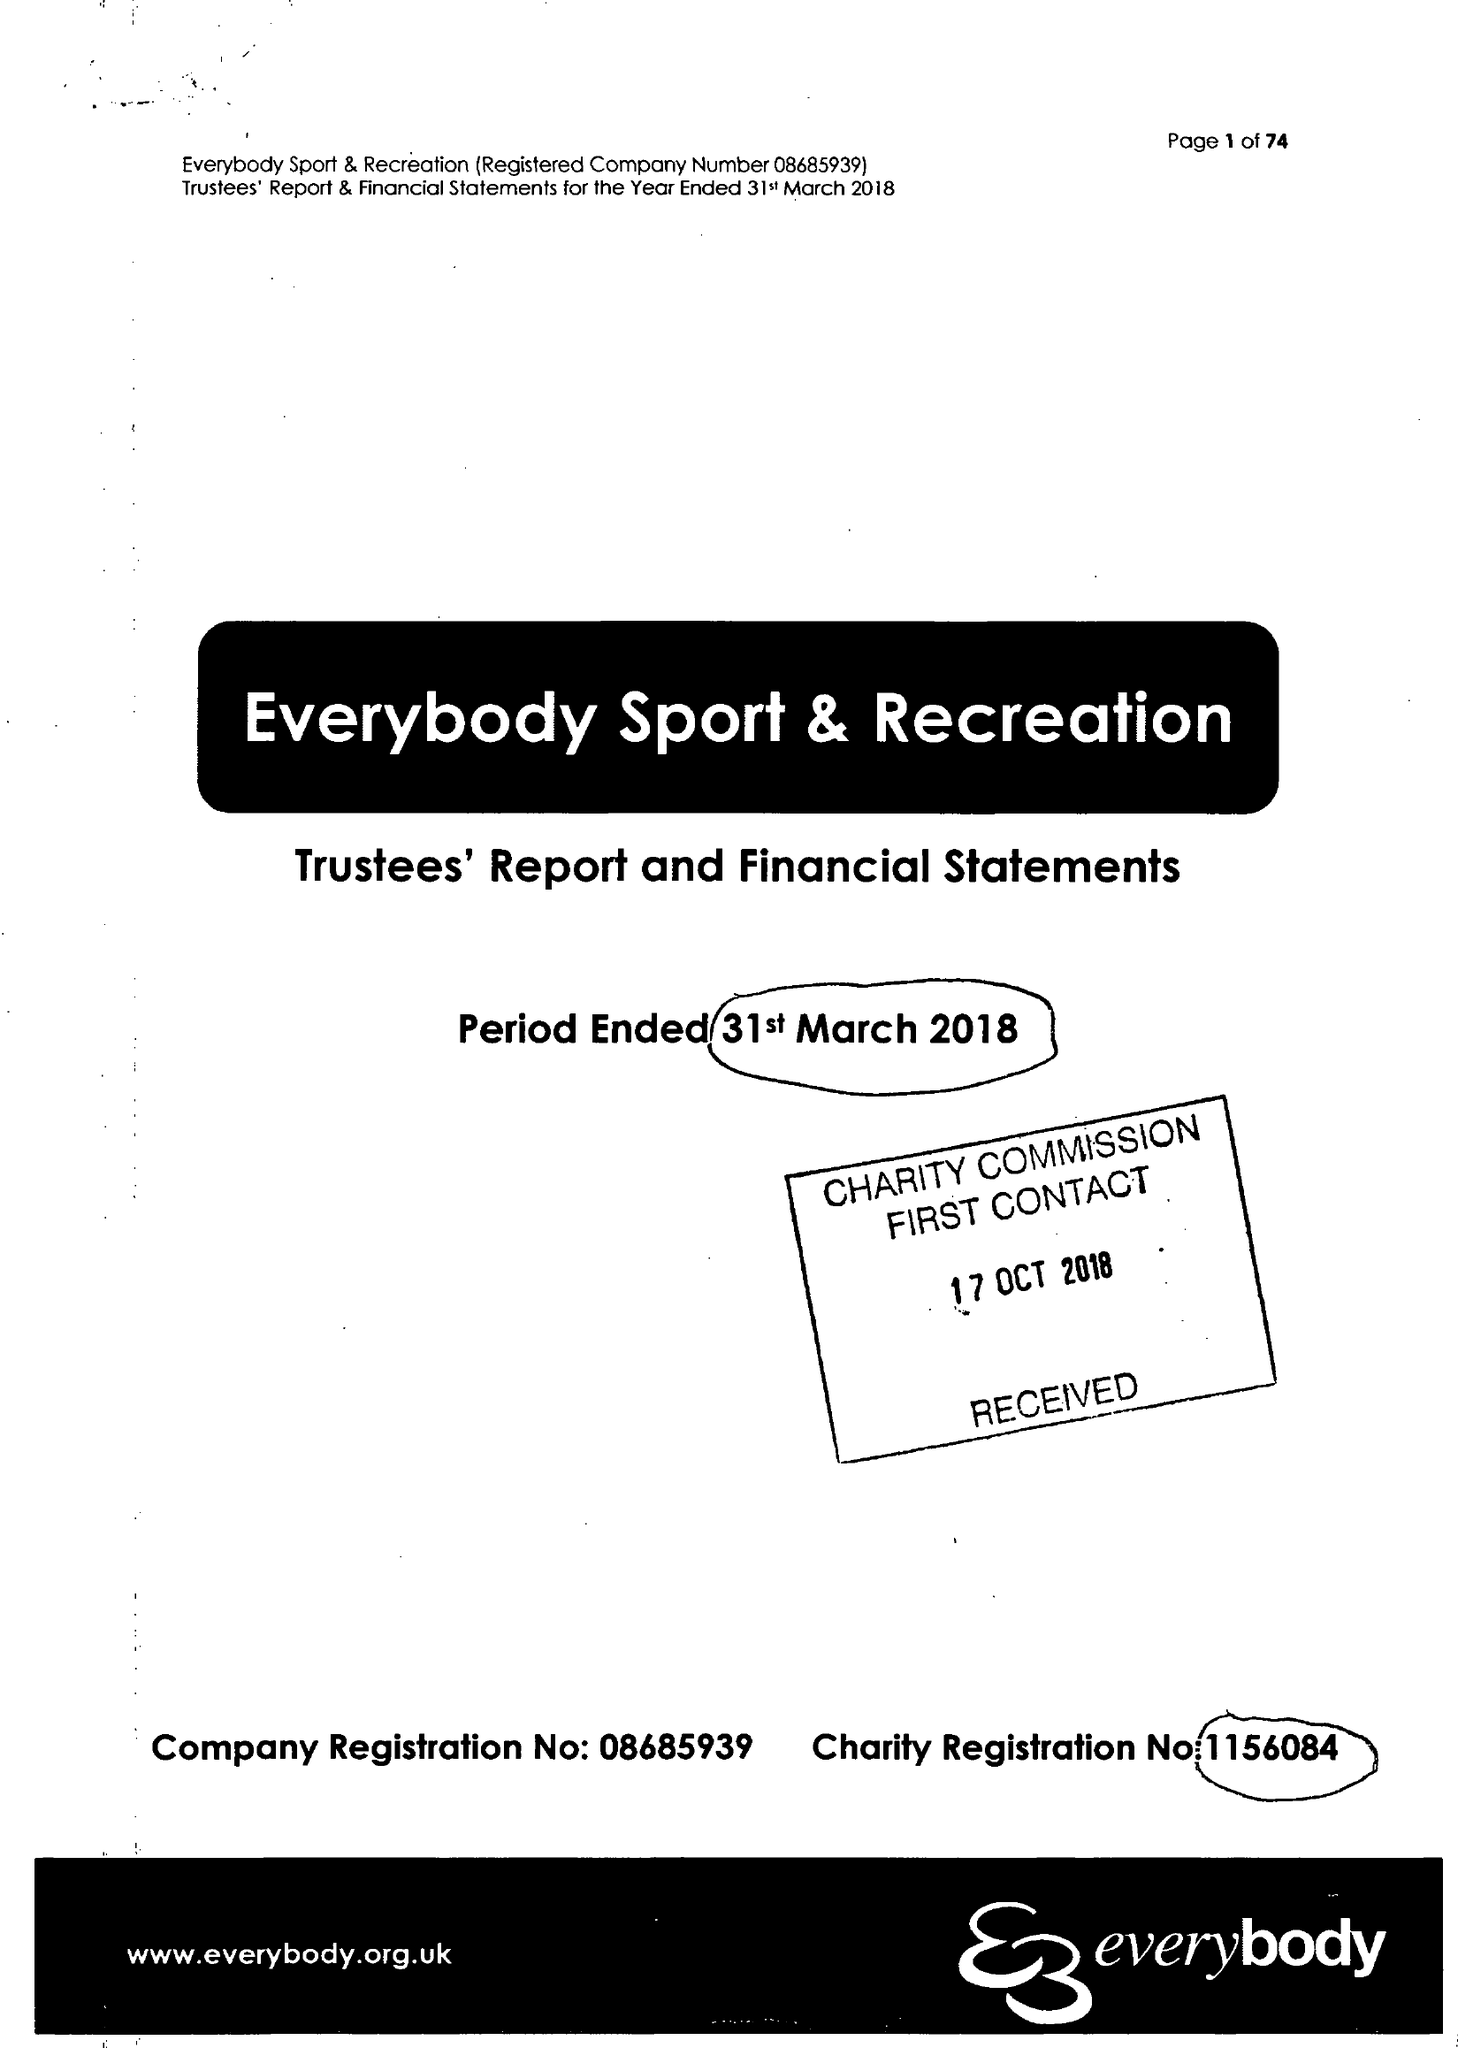What is the value for the report_date?
Answer the question using a single word or phrase. 2018-03-31 